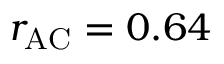Convert formula to latex. <formula><loc_0><loc_0><loc_500><loc_500>r _ { A C } = 0 . 6 4</formula> 